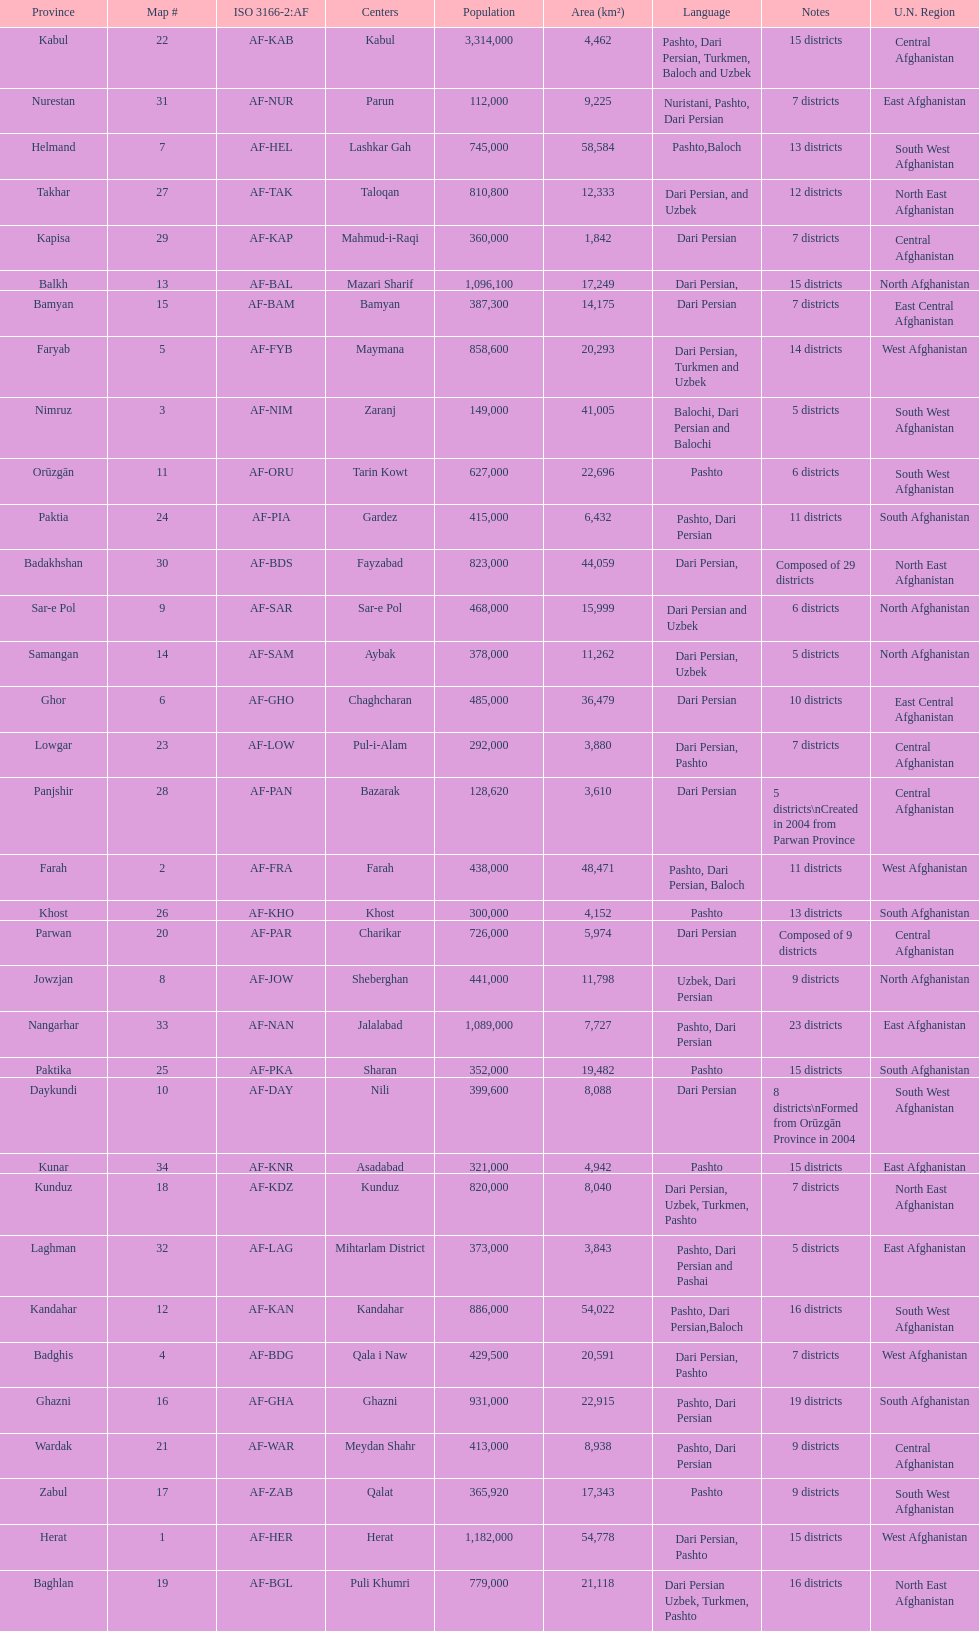How many provinces in afghanistan speak dari persian? 28. 